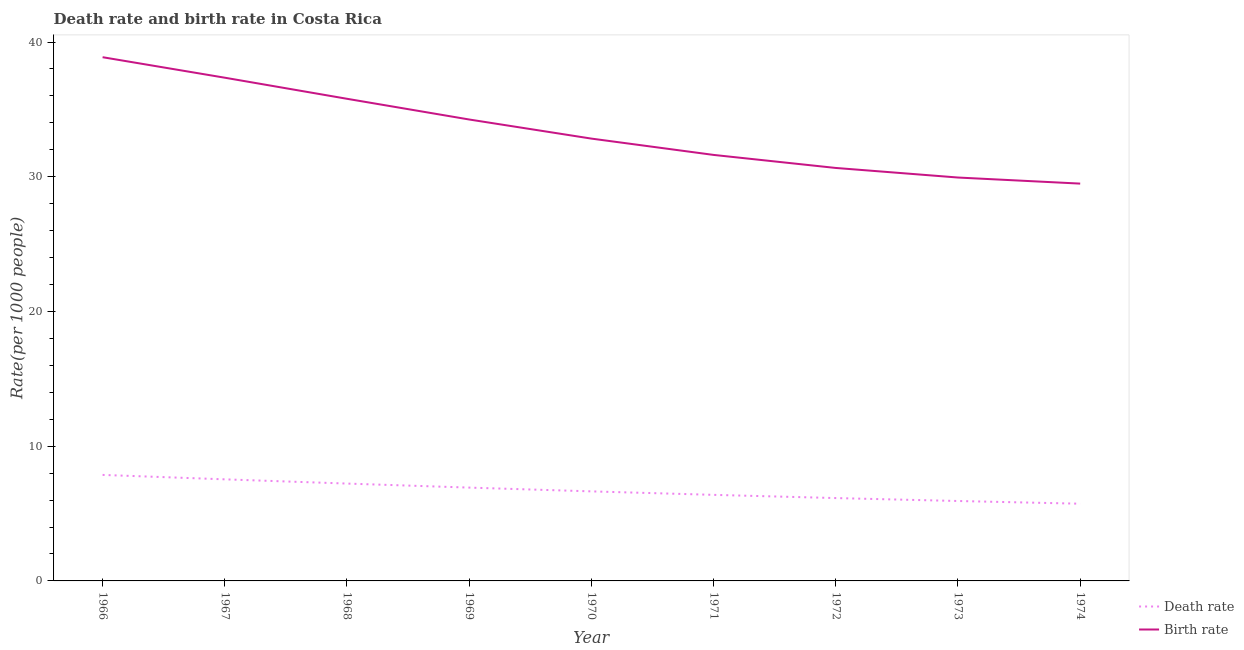Is the number of lines equal to the number of legend labels?
Ensure brevity in your answer.  Yes. What is the birth rate in 1970?
Give a very brief answer. 32.83. Across all years, what is the maximum death rate?
Your answer should be very brief. 7.87. Across all years, what is the minimum birth rate?
Give a very brief answer. 29.49. In which year was the death rate maximum?
Make the answer very short. 1966. In which year was the birth rate minimum?
Provide a short and direct response. 1974. What is the total death rate in the graph?
Your answer should be compact. 60.41. What is the difference between the birth rate in 1967 and that in 1973?
Make the answer very short. 7.41. What is the difference between the death rate in 1966 and the birth rate in 1970?
Your answer should be very brief. -24.96. What is the average birth rate per year?
Your response must be concise. 33.42. In the year 1972, what is the difference between the birth rate and death rate?
Your answer should be very brief. 24.5. In how many years, is the birth rate greater than 38?
Offer a very short reply. 1. What is the ratio of the birth rate in 1966 to that in 1973?
Your answer should be very brief. 1.3. What is the difference between the highest and the second highest death rate?
Your answer should be very brief. 0.33. What is the difference between the highest and the lowest birth rate?
Provide a short and direct response. 9.38. In how many years, is the death rate greater than the average death rate taken over all years?
Provide a short and direct response. 4. Is the sum of the death rate in 1968 and 1971 greater than the maximum birth rate across all years?
Your answer should be compact. No. Is the death rate strictly greater than the birth rate over the years?
Offer a very short reply. No. How many lines are there?
Ensure brevity in your answer.  2. How many years are there in the graph?
Your answer should be very brief. 9. What is the difference between two consecutive major ticks on the Y-axis?
Provide a short and direct response. 10. Does the graph contain any zero values?
Keep it short and to the point. No. Where does the legend appear in the graph?
Give a very brief answer. Bottom right. How many legend labels are there?
Your answer should be compact. 2. What is the title of the graph?
Your answer should be very brief. Death rate and birth rate in Costa Rica. What is the label or title of the Y-axis?
Your answer should be compact. Rate(per 1000 people). What is the Rate(per 1000 people) of Death rate in 1966?
Offer a terse response. 7.87. What is the Rate(per 1000 people) in Birth rate in 1966?
Make the answer very short. 38.87. What is the Rate(per 1000 people) of Death rate in 1967?
Make the answer very short. 7.54. What is the Rate(per 1000 people) in Birth rate in 1967?
Give a very brief answer. 37.35. What is the Rate(per 1000 people) of Death rate in 1968?
Your response must be concise. 7.23. What is the Rate(per 1000 people) in Birth rate in 1968?
Provide a short and direct response. 35.79. What is the Rate(per 1000 people) of Death rate in 1969?
Your answer should be very brief. 6.93. What is the Rate(per 1000 people) of Birth rate in 1969?
Offer a terse response. 34.25. What is the Rate(per 1000 people) of Death rate in 1970?
Ensure brevity in your answer.  6.65. What is the Rate(per 1000 people) in Birth rate in 1970?
Give a very brief answer. 32.83. What is the Rate(per 1000 people) of Death rate in 1971?
Offer a very short reply. 6.39. What is the Rate(per 1000 people) in Birth rate in 1971?
Offer a terse response. 31.62. What is the Rate(per 1000 people) of Death rate in 1972?
Your answer should be very brief. 6.15. What is the Rate(per 1000 people) of Birth rate in 1972?
Offer a very short reply. 30.65. What is the Rate(per 1000 people) in Death rate in 1973?
Offer a terse response. 5.93. What is the Rate(per 1000 people) in Birth rate in 1973?
Your answer should be compact. 29.94. What is the Rate(per 1000 people) of Death rate in 1974?
Offer a very short reply. 5.73. What is the Rate(per 1000 people) in Birth rate in 1974?
Your answer should be compact. 29.49. Across all years, what is the maximum Rate(per 1000 people) of Death rate?
Ensure brevity in your answer.  7.87. Across all years, what is the maximum Rate(per 1000 people) of Birth rate?
Make the answer very short. 38.87. Across all years, what is the minimum Rate(per 1000 people) in Death rate?
Provide a succinct answer. 5.73. Across all years, what is the minimum Rate(per 1000 people) of Birth rate?
Provide a short and direct response. 29.49. What is the total Rate(per 1000 people) of Death rate in the graph?
Keep it short and to the point. 60.41. What is the total Rate(per 1000 people) in Birth rate in the graph?
Your response must be concise. 300.8. What is the difference between the Rate(per 1000 people) in Death rate in 1966 and that in 1967?
Your answer should be compact. 0.33. What is the difference between the Rate(per 1000 people) of Birth rate in 1966 and that in 1967?
Offer a terse response. 1.52. What is the difference between the Rate(per 1000 people) of Death rate in 1966 and that in 1968?
Your answer should be compact. 0.64. What is the difference between the Rate(per 1000 people) in Birth rate in 1966 and that in 1968?
Offer a terse response. 3.09. What is the difference between the Rate(per 1000 people) in Death rate in 1966 and that in 1969?
Your response must be concise. 0.94. What is the difference between the Rate(per 1000 people) of Birth rate in 1966 and that in 1969?
Provide a succinct answer. 4.62. What is the difference between the Rate(per 1000 people) of Death rate in 1966 and that in 1970?
Your response must be concise. 1.22. What is the difference between the Rate(per 1000 people) of Birth rate in 1966 and that in 1970?
Give a very brief answer. 6.04. What is the difference between the Rate(per 1000 people) of Death rate in 1966 and that in 1971?
Your response must be concise. 1.48. What is the difference between the Rate(per 1000 people) in Birth rate in 1966 and that in 1971?
Offer a terse response. 7.25. What is the difference between the Rate(per 1000 people) in Death rate in 1966 and that in 1972?
Provide a short and direct response. 1.72. What is the difference between the Rate(per 1000 people) in Birth rate in 1966 and that in 1972?
Your response must be concise. 8.22. What is the difference between the Rate(per 1000 people) in Death rate in 1966 and that in 1973?
Your answer should be compact. 1.94. What is the difference between the Rate(per 1000 people) in Birth rate in 1966 and that in 1973?
Give a very brief answer. 8.93. What is the difference between the Rate(per 1000 people) in Death rate in 1966 and that in 1974?
Provide a succinct answer. 2.14. What is the difference between the Rate(per 1000 people) of Birth rate in 1966 and that in 1974?
Offer a very short reply. 9.38. What is the difference between the Rate(per 1000 people) in Death rate in 1967 and that in 1968?
Offer a very short reply. 0.31. What is the difference between the Rate(per 1000 people) in Birth rate in 1967 and that in 1968?
Keep it short and to the point. 1.56. What is the difference between the Rate(per 1000 people) of Death rate in 1967 and that in 1969?
Keep it short and to the point. 0.61. What is the difference between the Rate(per 1000 people) in Birth rate in 1967 and that in 1969?
Your answer should be very brief. 3.1. What is the difference between the Rate(per 1000 people) of Death rate in 1967 and that in 1970?
Give a very brief answer. 0.89. What is the difference between the Rate(per 1000 people) of Birth rate in 1967 and that in 1970?
Offer a terse response. 4.52. What is the difference between the Rate(per 1000 people) of Death rate in 1967 and that in 1971?
Your response must be concise. 1.15. What is the difference between the Rate(per 1000 people) in Birth rate in 1967 and that in 1971?
Keep it short and to the point. 5.73. What is the difference between the Rate(per 1000 people) of Death rate in 1967 and that in 1972?
Ensure brevity in your answer.  1.39. What is the difference between the Rate(per 1000 people) in Birth rate in 1967 and that in 1972?
Keep it short and to the point. 6.7. What is the difference between the Rate(per 1000 people) in Death rate in 1967 and that in 1973?
Offer a very short reply. 1.61. What is the difference between the Rate(per 1000 people) in Birth rate in 1967 and that in 1973?
Ensure brevity in your answer.  7.41. What is the difference between the Rate(per 1000 people) in Death rate in 1967 and that in 1974?
Your answer should be very brief. 1.81. What is the difference between the Rate(per 1000 people) in Birth rate in 1967 and that in 1974?
Your answer should be compact. 7.86. What is the difference between the Rate(per 1000 people) of Death rate in 1968 and that in 1969?
Your answer should be very brief. 0.3. What is the difference between the Rate(per 1000 people) in Birth rate in 1968 and that in 1969?
Offer a terse response. 1.54. What is the difference between the Rate(per 1000 people) of Death rate in 1968 and that in 1970?
Offer a very short reply. 0.58. What is the difference between the Rate(per 1000 people) in Birth rate in 1968 and that in 1970?
Make the answer very short. 2.96. What is the difference between the Rate(per 1000 people) in Death rate in 1968 and that in 1971?
Your answer should be compact. 0.84. What is the difference between the Rate(per 1000 people) of Birth rate in 1968 and that in 1971?
Offer a very short reply. 4.17. What is the difference between the Rate(per 1000 people) of Death rate in 1968 and that in 1972?
Ensure brevity in your answer.  1.08. What is the difference between the Rate(per 1000 people) of Birth rate in 1968 and that in 1972?
Your answer should be compact. 5.13. What is the difference between the Rate(per 1000 people) in Death rate in 1968 and that in 1973?
Provide a short and direct response. 1.29. What is the difference between the Rate(per 1000 people) of Birth rate in 1968 and that in 1973?
Give a very brief answer. 5.84. What is the difference between the Rate(per 1000 people) in Death rate in 1968 and that in 1974?
Make the answer very short. 1.5. What is the difference between the Rate(per 1000 people) of Birth rate in 1968 and that in 1974?
Offer a terse response. 6.3. What is the difference between the Rate(per 1000 people) in Death rate in 1969 and that in 1970?
Keep it short and to the point. 0.28. What is the difference between the Rate(per 1000 people) of Birth rate in 1969 and that in 1970?
Provide a short and direct response. 1.42. What is the difference between the Rate(per 1000 people) in Death rate in 1969 and that in 1971?
Give a very brief answer. 0.54. What is the difference between the Rate(per 1000 people) of Birth rate in 1969 and that in 1971?
Ensure brevity in your answer.  2.63. What is the difference between the Rate(per 1000 people) of Death rate in 1969 and that in 1972?
Offer a terse response. 0.78. What is the difference between the Rate(per 1000 people) of Birth rate in 1969 and that in 1972?
Offer a terse response. 3.6. What is the difference between the Rate(per 1000 people) of Death rate in 1969 and that in 1973?
Ensure brevity in your answer.  0.99. What is the difference between the Rate(per 1000 people) of Birth rate in 1969 and that in 1973?
Your answer should be very brief. 4.31. What is the difference between the Rate(per 1000 people) in Death rate in 1969 and that in 1974?
Give a very brief answer. 1.2. What is the difference between the Rate(per 1000 people) of Birth rate in 1969 and that in 1974?
Make the answer very short. 4.76. What is the difference between the Rate(per 1000 people) in Death rate in 1970 and that in 1971?
Keep it short and to the point. 0.26. What is the difference between the Rate(per 1000 people) of Birth rate in 1970 and that in 1971?
Offer a terse response. 1.21. What is the difference between the Rate(per 1000 people) of Death rate in 1970 and that in 1972?
Provide a short and direct response. 0.5. What is the difference between the Rate(per 1000 people) of Birth rate in 1970 and that in 1972?
Keep it short and to the point. 2.18. What is the difference between the Rate(per 1000 people) in Death rate in 1970 and that in 1973?
Your answer should be compact. 0.71. What is the difference between the Rate(per 1000 people) of Birth rate in 1970 and that in 1973?
Provide a succinct answer. 2.89. What is the difference between the Rate(per 1000 people) in Death rate in 1970 and that in 1974?
Your answer should be very brief. 0.92. What is the difference between the Rate(per 1000 people) of Birth rate in 1970 and that in 1974?
Give a very brief answer. 3.34. What is the difference between the Rate(per 1000 people) of Death rate in 1971 and that in 1972?
Your answer should be compact. 0.24. What is the difference between the Rate(per 1000 people) in Death rate in 1971 and that in 1973?
Offer a terse response. 0.46. What is the difference between the Rate(per 1000 people) in Birth rate in 1971 and that in 1973?
Your answer should be compact. 1.68. What is the difference between the Rate(per 1000 people) in Death rate in 1971 and that in 1974?
Give a very brief answer. 0.66. What is the difference between the Rate(per 1000 people) of Birth rate in 1971 and that in 1974?
Your answer should be very brief. 2.13. What is the difference between the Rate(per 1000 people) of Death rate in 1972 and that in 1973?
Provide a short and direct response. 0.22. What is the difference between the Rate(per 1000 people) of Birth rate in 1972 and that in 1973?
Provide a succinct answer. 0.71. What is the difference between the Rate(per 1000 people) of Death rate in 1972 and that in 1974?
Provide a short and direct response. 0.42. What is the difference between the Rate(per 1000 people) of Birth rate in 1972 and that in 1974?
Your response must be concise. 1.16. What is the difference between the Rate(per 1000 people) in Death rate in 1973 and that in 1974?
Your answer should be compact. 0.2. What is the difference between the Rate(per 1000 people) in Birth rate in 1973 and that in 1974?
Ensure brevity in your answer.  0.45. What is the difference between the Rate(per 1000 people) in Death rate in 1966 and the Rate(per 1000 people) in Birth rate in 1967?
Keep it short and to the point. -29.48. What is the difference between the Rate(per 1000 people) of Death rate in 1966 and the Rate(per 1000 people) of Birth rate in 1968?
Your answer should be very brief. -27.92. What is the difference between the Rate(per 1000 people) in Death rate in 1966 and the Rate(per 1000 people) in Birth rate in 1969?
Ensure brevity in your answer.  -26.38. What is the difference between the Rate(per 1000 people) of Death rate in 1966 and the Rate(per 1000 people) of Birth rate in 1970?
Offer a terse response. -24.96. What is the difference between the Rate(per 1000 people) of Death rate in 1966 and the Rate(per 1000 people) of Birth rate in 1971?
Offer a terse response. -23.75. What is the difference between the Rate(per 1000 people) in Death rate in 1966 and the Rate(per 1000 people) in Birth rate in 1972?
Offer a terse response. -22.78. What is the difference between the Rate(per 1000 people) of Death rate in 1966 and the Rate(per 1000 people) of Birth rate in 1973?
Your answer should be very brief. -22.07. What is the difference between the Rate(per 1000 people) in Death rate in 1966 and the Rate(per 1000 people) in Birth rate in 1974?
Make the answer very short. -21.62. What is the difference between the Rate(per 1000 people) in Death rate in 1967 and the Rate(per 1000 people) in Birth rate in 1968?
Give a very brief answer. -28.25. What is the difference between the Rate(per 1000 people) in Death rate in 1967 and the Rate(per 1000 people) in Birth rate in 1969?
Keep it short and to the point. -26.71. What is the difference between the Rate(per 1000 people) in Death rate in 1967 and the Rate(per 1000 people) in Birth rate in 1970?
Make the answer very short. -25.29. What is the difference between the Rate(per 1000 people) in Death rate in 1967 and the Rate(per 1000 people) in Birth rate in 1971?
Provide a succinct answer. -24.08. What is the difference between the Rate(per 1000 people) of Death rate in 1967 and the Rate(per 1000 people) of Birth rate in 1972?
Your answer should be compact. -23.11. What is the difference between the Rate(per 1000 people) in Death rate in 1967 and the Rate(per 1000 people) in Birth rate in 1973?
Give a very brief answer. -22.4. What is the difference between the Rate(per 1000 people) of Death rate in 1967 and the Rate(per 1000 people) of Birth rate in 1974?
Keep it short and to the point. -21.95. What is the difference between the Rate(per 1000 people) of Death rate in 1968 and the Rate(per 1000 people) of Birth rate in 1969?
Offer a terse response. -27.02. What is the difference between the Rate(per 1000 people) of Death rate in 1968 and the Rate(per 1000 people) of Birth rate in 1970?
Give a very brief answer. -25.61. What is the difference between the Rate(per 1000 people) of Death rate in 1968 and the Rate(per 1000 people) of Birth rate in 1971?
Ensure brevity in your answer.  -24.39. What is the difference between the Rate(per 1000 people) in Death rate in 1968 and the Rate(per 1000 people) in Birth rate in 1972?
Keep it short and to the point. -23.43. What is the difference between the Rate(per 1000 people) of Death rate in 1968 and the Rate(per 1000 people) of Birth rate in 1973?
Offer a very short reply. -22.72. What is the difference between the Rate(per 1000 people) in Death rate in 1968 and the Rate(per 1000 people) in Birth rate in 1974?
Provide a short and direct response. -22.27. What is the difference between the Rate(per 1000 people) in Death rate in 1969 and the Rate(per 1000 people) in Birth rate in 1970?
Ensure brevity in your answer.  -25.91. What is the difference between the Rate(per 1000 people) of Death rate in 1969 and the Rate(per 1000 people) of Birth rate in 1971?
Provide a succinct answer. -24.69. What is the difference between the Rate(per 1000 people) in Death rate in 1969 and the Rate(per 1000 people) in Birth rate in 1972?
Offer a terse response. -23.73. What is the difference between the Rate(per 1000 people) of Death rate in 1969 and the Rate(per 1000 people) of Birth rate in 1973?
Provide a succinct answer. -23.02. What is the difference between the Rate(per 1000 people) of Death rate in 1969 and the Rate(per 1000 people) of Birth rate in 1974?
Ensure brevity in your answer.  -22.56. What is the difference between the Rate(per 1000 people) in Death rate in 1970 and the Rate(per 1000 people) in Birth rate in 1971?
Offer a very short reply. -24.97. What is the difference between the Rate(per 1000 people) of Death rate in 1970 and the Rate(per 1000 people) of Birth rate in 1972?
Give a very brief answer. -24.01. What is the difference between the Rate(per 1000 people) of Death rate in 1970 and the Rate(per 1000 people) of Birth rate in 1973?
Provide a succinct answer. -23.3. What is the difference between the Rate(per 1000 people) in Death rate in 1970 and the Rate(per 1000 people) in Birth rate in 1974?
Your answer should be very brief. -22.84. What is the difference between the Rate(per 1000 people) of Death rate in 1971 and the Rate(per 1000 people) of Birth rate in 1972?
Keep it short and to the point. -24.27. What is the difference between the Rate(per 1000 people) in Death rate in 1971 and the Rate(per 1000 people) in Birth rate in 1973?
Provide a short and direct response. -23.55. What is the difference between the Rate(per 1000 people) in Death rate in 1971 and the Rate(per 1000 people) in Birth rate in 1974?
Give a very brief answer. -23.1. What is the difference between the Rate(per 1000 people) in Death rate in 1972 and the Rate(per 1000 people) in Birth rate in 1973?
Offer a terse response. -23.79. What is the difference between the Rate(per 1000 people) in Death rate in 1972 and the Rate(per 1000 people) in Birth rate in 1974?
Your response must be concise. -23.34. What is the difference between the Rate(per 1000 people) of Death rate in 1973 and the Rate(per 1000 people) of Birth rate in 1974?
Provide a short and direct response. -23.56. What is the average Rate(per 1000 people) in Death rate per year?
Make the answer very short. 6.71. What is the average Rate(per 1000 people) in Birth rate per year?
Provide a succinct answer. 33.42. In the year 1966, what is the difference between the Rate(per 1000 people) in Death rate and Rate(per 1000 people) in Birth rate?
Your answer should be very brief. -31. In the year 1967, what is the difference between the Rate(per 1000 people) in Death rate and Rate(per 1000 people) in Birth rate?
Offer a very short reply. -29.81. In the year 1968, what is the difference between the Rate(per 1000 people) in Death rate and Rate(per 1000 people) in Birth rate?
Ensure brevity in your answer.  -28.56. In the year 1969, what is the difference between the Rate(per 1000 people) in Death rate and Rate(per 1000 people) in Birth rate?
Your answer should be very brief. -27.32. In the year 1970, what is the difference between the Rate(per 1000 people) of Death rate and Rate(per 1000 people) of Birth rate?
Give a very brief answer. -26.18. In the year 1971, what is the difference between the Rate(per 1000 people) in Death rate and Rate(per 1000 people) in Birth rate?
Keep it short and to the point. -25.23. In the year 1972, what is the difference between the Rate(per 1000 people) of Death rate and Rate(per 1000 people) of Birth rate?
Ensure brevity in your answer.  -24.5. In the year 1973, what is the difference between the Rate(per 1000 people) of Death rate and Rate(per 1000 people) of Birth rate?
Offer a very short reply. -24.01. In the year 1974, what is the difference between the Rate(per 1000 people) of Death rate and Rate(per 1000 people) of Birth rate?
Make the answer very short. -23.76. What is the ratio of the Rate(per 1000 people) of Death rate in 1966 to that in 1967?
Your answer should be compact. 1.04. What is the ratio of the Rate(per 1000 people) in Birth rate in 1966 to that in 1967?
Provide a short and direct response. 1.04. What is the ratio of the Rate(per 1000 people) in Death rate in 1966 to that in 1968?
Your answer should be very brief. 1.09. What is the ratio of the Rate(per 1000 people) in Birth rate in 1966 to that in 1968?
Keep it short and to the point. 1.09. What is the ratio of the Rate(per 1000 people) of Death rate in 1966 to that in 1969?
Keep it short and to the point. 1.14. What is the ratio of the Rate(per 1000 people) in Birth rate in 1966 to that in 1969?
Your answer should be very brief. 1.14. What is the ratio of the Rate(per 1000 people) in Death rate in 1966 to that in 1970?
Ensure brevity in your answer.  1.18. What is the ratio of the Rate(per 1000 people) of Birth rate in 1966 to that in 1970?
Your answer should be very brief. 1.18. What is the ratio of the Rate(per 1000 people) of Death rate in 1966 to that in 1971?
Make the answer very short. 1.23. What is the ratio of the Rate(per 1000 people) in Birth rate in 1966 to that in 1971?
Provide a succinct answer. 1.23. What is the ratio of the Rate(per 1000 people) in Death rate in 1966 to that in 1972?
Your response must be concise. 1.28. What is the ratio of the Rate(per 1000 people) in Birth rate in 1966 to that in 1972?
Your answer should be compact. 1.27. What is the ratio of the Rate(per 1000 people) in Death rate in 1966 to that in 1973?
Provide a short and direct response. 1.33. What is the ratio of the Rate(per 1000 people) of Birth rate in 1966 to that in 1973?
Your answer should be very brief. 1.3. What is the ratio of the Rate(per 1000 people) in Death rate in 1966 to that in 1974?
Offer a very short reply. 1.37. What is the ratio of the Rate(per 1000 people) of Birth rate in 1966 to that in 1974?
Make the answer very short. 1.32. What is the ratio of the Rate(per 1000 people) of Death rate in 1967 to that in 1968?
Give a very brief answer. 1.04. What is the ratio of the Rate(per 1000 people) of Birth rate in 1967 to that in 1968?
Offer a terse response. 1.04. What is the ratio of the Rate(per 1000 people) in Death rate in 1967 to that in 1969?
Your response must be concise. 1.09. What is the ratio of the Rate(per 1000 people) of Birth rate in 1967 to that in 1969?
Offer a terse response. 1.09. What is the ratio of the Rate(per 1000 people) of Death rate in 1967 to that in 1970?
Provide a short and direct response. 1.13. What is the ratio of the Rate(per 1000 people) of Birth rate in 1967 to that in 1970?
Ensure brevity in your answer.  1.14. What is the ratio of the Rate(per 1000 people) in Death rate in 1967 to that in 1971?
Provide a short and direct response. 1.18. What is the ratio of the Rate(per 1000 people) in Birth rate in 1967 to that in 1971?
Ensure brevity in your answer.  1.18. What is the ratio of the Rate(per 1000 people) of Death rate in 1967 to that in 1972?
Offer a terse response. 1.23. What is the ratio of the Rate(per 1000 people) of Birth rate in 1967 to that in 1972?
Your response must be concise. 1.22. What is the ratio of the Rate(per 1000 people) of Death rate in 1967 to that in 1973?
Provide a short and direct response. 1.27. What is the ratio of the Rate(per 1000 people) in Birth rate in 1967 to that in 1973?
Provide a short and direct response. 1.25. What is the ratio of the Rate(per 1000 people) in Death rate in 1967 to that in 1974?
Keep it short and to the point. 1.32. What is the ratio of the Rate(per 1000 people) of Birth rate in 1967 to that in 1974?
Make the answer very short. 1.27. What is the ratio of the Rate(per 1000 people) of Death rate in 1968 to that in 1969?
Make the answer very short. 1.04. What is the ratio of the Rate(per 1000 people) in Birth rate in 1968 to that in 1969?
Make the answer very short. 1.04. What is the ratio of the Rate(per 1000 people) in Death rate in 1968 to that in 1970?
Your answer should be very brief. 1.09. What is the ratio of the Rate(per 1000 people) in Birth rate in 1968 to that in 1970?
Your response must be concise. 1.09. What is the ratio of the Rate(per 1000 people) of Death rate in 1968 to that in 1971?
Offer a very short reply. 1.13. What is the ratio of the Rate(per 1000 people) in Birth rate in 1968 to that in 1971?
Make the answer very short. 1.13. What is the ratio of the Rate(per 1000 people) of Death rate in 1968 to that in 1972?
Provide a succinct answer. 1.18. What is the ratio of the Rate(per 1000 people) of Birth rate in 1968 to that in 1972?
Provide a succinct answer. 1.17. What is the ratio of the Rate(per 1000 people) in Death rate in 1968 to that in 1973?
Your answer should be very brief. 1.22. What is the ratio of the Rate(per 1000 people) of Birth rate in 1968 to that in 1973?
Make the answer very short. 1.2. What is the ratio of the Rate(per 1000 people) in Death rate in 1968 to that in 1974?
Keep it short and to the point. 1.26. What is the ratio of the Rate(per 1000 people) in Birth rate in 1968 to that in 1974?
Keep it short and to the point. 1.21. What is the ratio of the Rate(per 1000 people) of Death rate in 1969 to that in 1970?
Keep it short and to the point. 1.04. What is the ratio of the Rate(per 1000 people) of Birth rate in 1969 to that in 1970?
Offer a terse response. 1.04. What is the ratio of the Rate(per 1000 people) of Death rate in 1969 to that in 1971?
Offer a very short reply. 1.08. What is the ratio of the Rate(per 1000 people) of Birth rate in 1969 to that in 1971?
Provide a short and direct response. 1.08. What is the ratio of the Rate(per 1000 people) in Death rate in 1969 to that in 1972?
Offer a terse response. 1.13. What is the ratio of the Rate(per 1000 people) of Birth rate in 1969 to that in 1972?
Offer a terse response. 1.12. What is the ratio of the Rate(per 1000 people) of Death rate in 1969 to that in 1973?
Make the answer very short. 1.17. What is the ratio of the Rate(per 1000 people) in Birth rate in 1969 to that in 1973?
Make the answer very short. 1.14. What is the ratio of the Rate(per 1000 people) of Death rate in 1969 to that in 1974?
Offer a very short reply. 1.21. What is the ratio of the Rate(per 1000 people) of Birth rate in 1969 to that in 1974?
Your response must be concise. 1.16. What is the ratio of the Rate(per 1000 people) in Death rate in 1970 to that in 1971?
Your answer should be very brief. 1.04. What is the ratio of the Rate(per 1000 people) of Birth rate in 1970 to that in 1971?
Your answer should be very brief. 1.04. What is the ratio of the Rate(per 1000 people) in Death rate in 1970 to that in 1972?
Your answer should be very brief. 1.08. What is the ratio of the Rate(per 1000 people) of Birth rate in 1970 to that in 1972?
Keep it short and to the point. 1.07. What is the ratio of the Rate(per 1000 people) of Death rate in 1970 to that in 1973?
Your answer should be compact. 1.12. What is the ratio of the Rate(per 1000 people) in Birth rate in 1970 to that in 1973?
Ensure brevity in your answer.  1.1. What is the ratio of the Rate(per 1000 people) in Death rate in 1970 to that in 1974?
Offer a very short reply. 1.16. What is the ratio of the Rate(per 1000 people) in Birth rate in 1970 to that in 1974?
Give a very brief answer. 1.11. What is the ratio of the Rate(per 1000 people) of Death rate in 1971 to that in 1972?
Your answer should be very brief. 1.04. What is the ratio of the Rate(per 1000 people) of Birth rate in 1971 to that in 1972?
Offer a very short reply. 1.03. What is the ratio of the Rate(per 1000 people) in Birth rate in 1971 to that in 1973?
Offer a very short reply. 1.06. What is the ratio of the Rate(per 1000 people) in Death rate in 1971 to that in 1974?
Provide a short and direct response. 1.11. What is the ratio of the Rate(per 1000 people) of Birth rate in 1971 to that in 1974?
Give a very brief answer. 1.07. What is the ratio of the Rate(per 1000 people) of Death rate in 1972 to that in 1973?
Make the answer very short. 1.04. What is the ratio of the Rate(per 1000 people) of Birth rate in 1972 to that in 1973?
Keep it short and to the point. 1.02. What is the ratio of the Rate(per 1000 people) in Death rate in 1972 to that in 1974?
Make the answer very short. 1.07. What is the ratio of the Rate(per 1000 people) in Birth rate in 1972 to that in 1974?
Your response must be concise. 1.04. What is the ratio of the Rate(per 1000 people) of Death rate in 1973 to that in 1974?
Provide a short and direct response. 1.04. What is the ratio of the Rate(per 1000 people) in Birth rate in 1973 to that in 1974?
Keep it short and to the point. 1.02. What is the difference between the highest and the second highest Rate(per 1000 people) in Death rate?
Make the answer very short. 0.33. What is the difference between the highest and the second highest Rate(per 1000 people) of Birth rate?
Give a very brief answer. 1.52. What is the difference between the highest and the lowest Rate(per 1000 people) of Death rate?
Offer a very short reply. 2.14. What is the difference between the highest and the lowest Rate(per 1000 people) in Birth rate?
Make the answer very short. 9.38. 